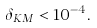Convert formula to latex. <formula><loc_0><loc_0><loc_500><loc_500>\delta _ { K M } < { 1 0 } ^ { - 4 } .</formula> 